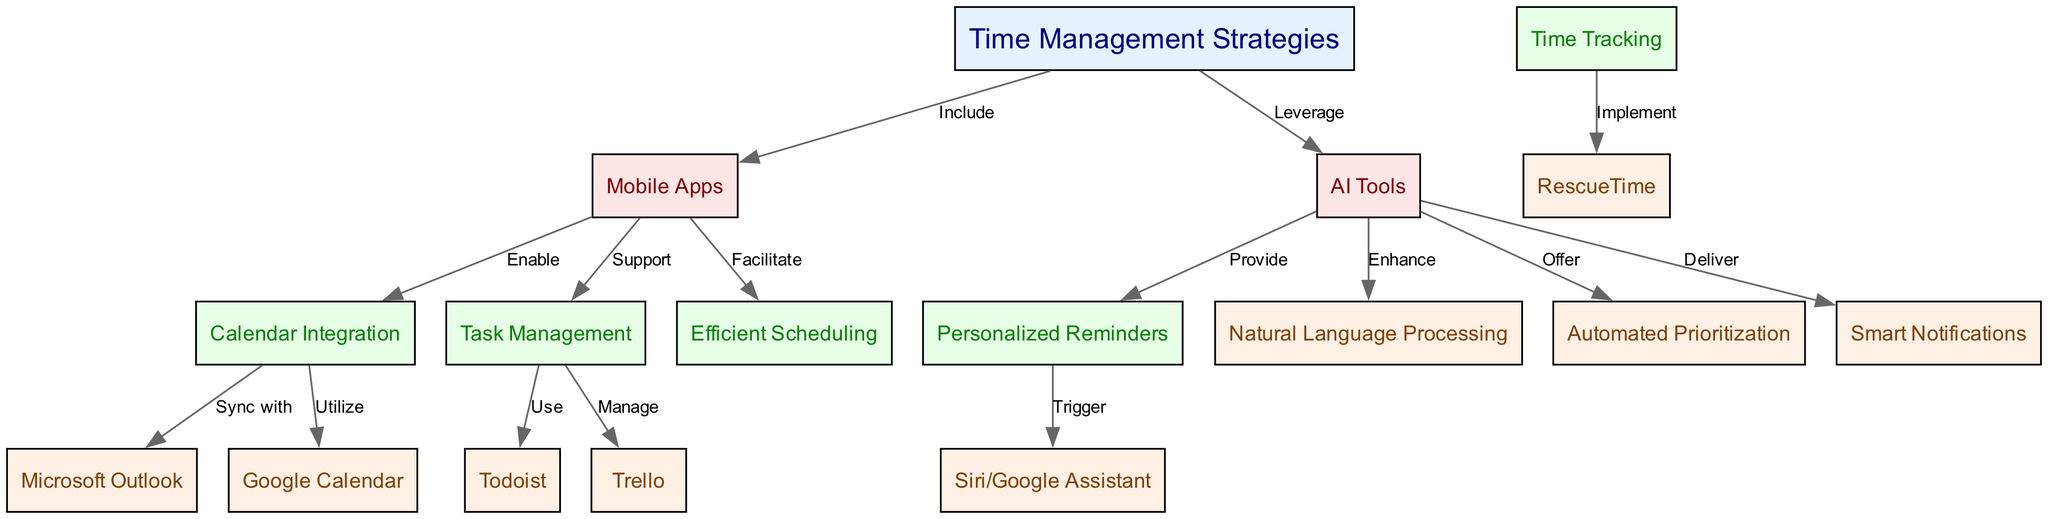What are the primary categories of tools for time management strategies? The diagram shows two primary categories: Mobile Apps and AI Tools, which are linked to the central strategy of Time Management Strategies.
Answer: Mobile Apps, AI Tools How many nodes are in the diagram? By counting the entries in the 'nodes' section of the diagram data, we find there are 17 nodes in total.
Answer: 17 What strategy enables calendar integration? The Mobile Apps section includes a node labeled "Calendar Integration," indicating that this specific feature is enabled by Mobile Apps.
Answer: Mobile Apps Which task management tool is mentioned in the diagram? Under the Task Management node, there are two specified tools, Todoist and Trello; either is a valid answer as they both fall under this category.
Answer: Todoist, Trello What type of notifications do AI Tools deliver? The AI Tools section includes a node labeled "Smart Notifications," indicating that this is what AI Tools deliver.
Answer: Smart Notifications List the relationship between AI Tools and Personalized Reminders. The edge from AI Tools to Personalized Reminders is labeled "Provide," indicating that AI Tools provide Personalized Reminders.
Answer: Provide Which mobile app can sync with Microsoft Outlook? The diagram shows "Calendar Integration" linked directly with "Microsoft Outlook," hence any mobile app utilizing calendar features can sync with it.
Answer: Any mobile app with calendar integration How are task management tools supported by mobile apps? The diagram illustrates that Mobile Apps support Task Management, indicating that this is how these tools assist users in organizing tasks.
Answer: Support What is the role of Natural Language Processing in AI Tools? The connection from AI Tools to Natural Language Processing, labeled "Enhance," indicates that NLP enhances the functionality of AI tools in time management.
Answer: Enhance 